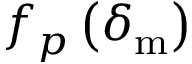Convert formula to latex. <formula><loc_0><loc_0><loc_500><loc_500>f _ { p } \left ( \delta _ { m } \right )</formula> 